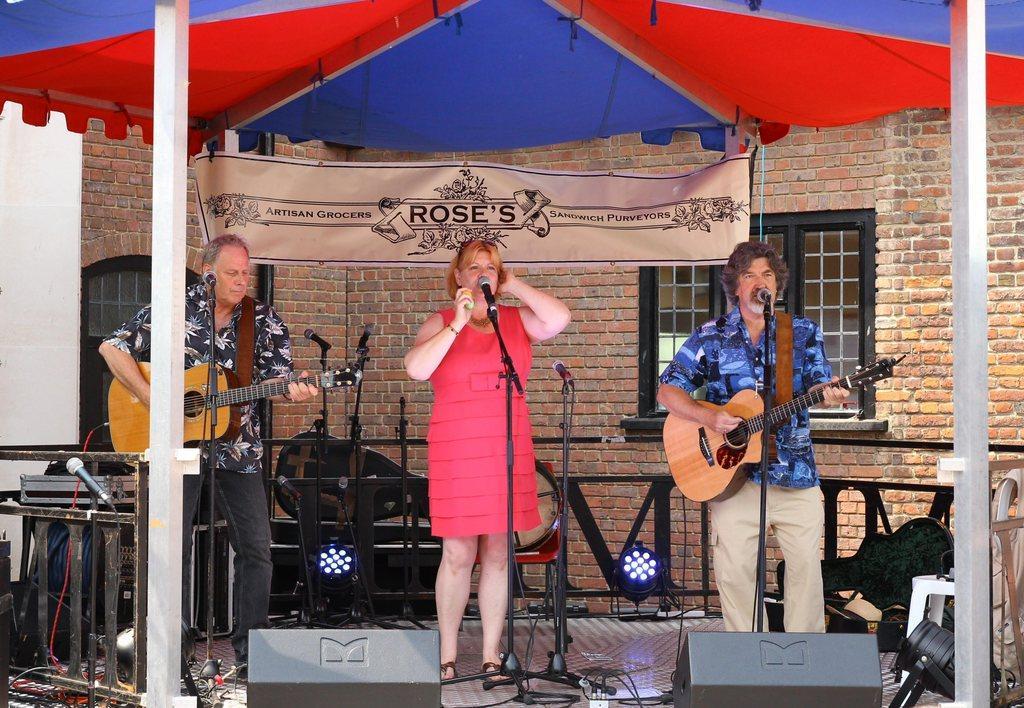Please provide a concise description of this image. There are 3 people on a standing in a stage. In the center of girl is singing a song. On the right side we have a black shirt person. He is holding a guitar. His playing guitar. On the left side we have a blue shirt person. His also holding a guitar. His also playing a guitar. We can in the background there is a tent,poster and some wall bricks. 